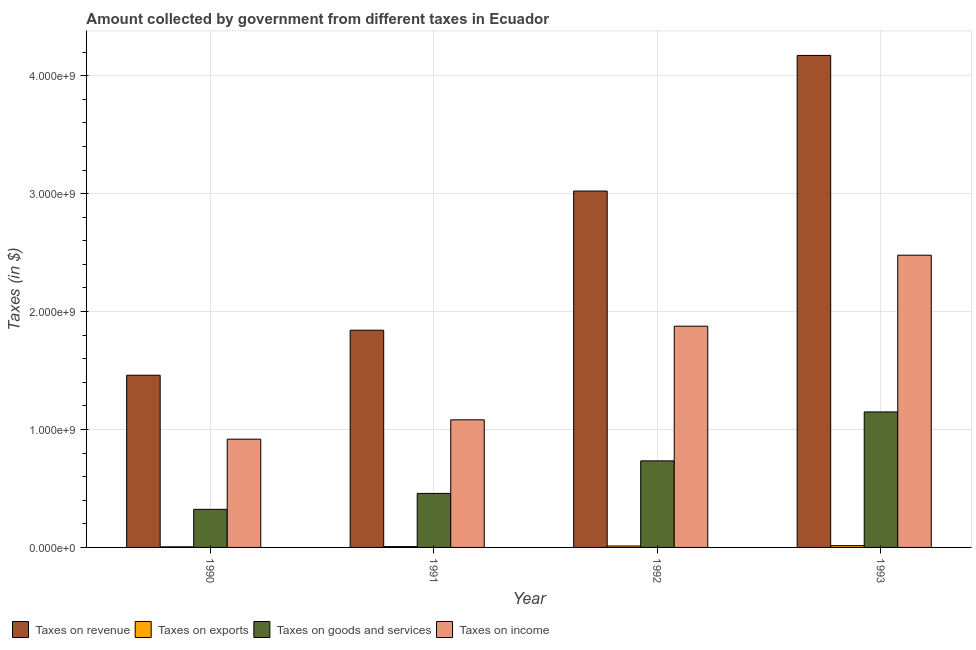How many different coloured bars are there?
Ensure brevity in your answer.  4. How many groups of bars are there?
Offer a very short reply. 4. Are the number of bars per tick equal to the number of legend labels?
Provide a succinct answer. Yes. How many bars are there on the 3rd tick from the right?
Ensure brevity in your answer.  4. What is the label of the 2nd group of bars from the left?
Provide a succinct answer. 1991. In how many cases, is the number of bars for a given year not equal to the number of legend labels?
Give a very brief answer. 0. What is the amount collected as tax on exports in 1993?
Provide a succinct answer. 1.50e+07. Across all years, what is the maximum amount collected as tax on goods?
Keep it short and to the point. 1.15e+09. Across all years, what is the minimum amount collected as tax on income?
Ensure brevity in your answer.  9.18e+08. What is the total amount collected as tax on revenue in the graph?
Your response must be concise. 1.05e+1. What is the difference between the amount collected as tax on revenue in 1990 and that in 1991?
Your answer should be very brief. -3.82e+08. What is the difference between the amount collected as tax on income in 1993 and the amount collected as tax on exports in 1991?
Your answer should be compact. 1.40e+09. What is the average amount collected as tax on exports per year?
Ensure brevity in your answer.  9.75e+06. In the year 1990, what is the difference between the amount collected as tax on income and amount collected as tax on revenue?
Offer a very short reply. 0. What is the ratio of the amount collected as tax on revenue in 1991 to that in 1993?
Make the answer very short. 0.44. What is the difference between the highest and the second highest amount collected as tax on revenue?
Offer a terse response. 1.15e+09. What is the difference between the highest and the lowest amount collected as tax on income?
Ensure brevity in your answer.  1.56e+09. Is the sum of the amount collected as tax on income in 1992 and 1993 greater than the maximum amount collected as tax on revenue across all years?
Provide a succinct answer. Yes. What does the 1st bar from the left in 1991 represents?
Make the answer very short. Taxes on revenue. What does the 1st bar from the right in 1993 represents?
Keep it short and to the point. Taxes on income. How many bars are there?
Your response must be concise. 16. Are all the bars in the graph horizontal?
Make the answer very short. No. Are the values on the major ticks of Y-axis written in scientific E-notation?
Your answer should be very brief. Yes. Does the graph contain any zero values?
Ensure brevity in your answer.  No. What is the title of the graph?
Your answer should be compact. Amount collected by government from different taxes in Ecuador. Does "Gender equality" appear as one of the legend labels in the graph?
Keep it short and to the point. No. What is the label or title of the Y-axis?
Your answer should be compact. Taxes (in $). What is the Taxes (in $) in Taxes on revenue in 1990?
Your answer should be compact. 1.46e+09. What is the Taxes (in $) in Taxes on exports in 1990?
Provide a short and direct response. 5.00e+06. What is the Taxes (in $) in Taxes on goods and services in 1990?
Keep it short and to the point. 3.23e+08. What is the Taxes (in $) in Taxes on income in 1990?
Provide a succinct answer. 9.18e+08. What is the Taxes (in $) in Taxes on revenue in 1991?
Offer a terse response. 1.84e+09. What is the Taxes (in $) in Taxes on exports in 1991?
Your answer should be compact. 7.00e+06. What is the Taxes (in $) of Taxes on goods and services in 1991?
Keep it short and to the point. 4.58e+08. What is the Taxes (in $) of Taxes on income in 1991?
Keep it short and to the point. 1.08e+09. What is the Taxes (in $) in Taxes on revenue in 1992?
Provide a succinct answer. 3.02e+09. What is the Taxes (in $) in Taxes on goods and services in 1992?
Your answer should be compact. 7.34e+08. What is the Taxes (in $) in Taxes on income in 1992?
Provide a succinct answer. 1.88e+09. What is the Taxes (in $) of Taxes on revenue in 1993?
Provide a succinct answer. 4.17e+09. What is the Taxes (in $) of Taxes on exports in 1993?
Give a very brief answer. 1.50e+07. What is the Taxes (in $) of Taxes on goods and services in 1993?
Provide a succinct answer. 1.15e+09. What is the Taxes (in $) in Taxes on income in 1993?
Your response must be concise. 2.48e+09. Across all years, what is the maximum Taxes (in $) in Taxes on revenue?
Make the answer very short. 4.17e+09. Across all years, what is the maximum Taxes (in $) of Taxes on exports?
Provide a succinct answer. 1.50e+07. Across all years, what is the maximum Taxes (in $) in Taxes on goods and services?
Keep it short and to the point. 1.15e+09. Across all years, what is the maximum Taxes (in $) in Taxes on income?
Make the answer very short. 2.48e+09. Across all years, what is the minimum Taxes (in $) in Taxes on revenue?
Give a very brief answer. 1.46e+09. Across all years, what is the minimum Taxes (in $) in Taxes on exports?
Keep it short and to the point. 5.00e+06. Across all years, what is the minimum Taxes (in $) of Taxes on goods and services?
Ensure brevity in your answer.  3.23e+08. Across all years, what is the minimum Taxes (in $) of Taxes on income?
Your answer should be compact. 9.18e+08. What is the total Taxes (in $) in Taxes on revenue in the graph?
Give a very brief answer. 1.05e+1. What is the total Taxes (in $) in Taxes on exports in the graph?
Keep it short and to the point. 3.90e+07. What is the total Taxes (in $) of Taxes on goods and services in the graph?
Your answer should be compact. 2.66e+09. What is the total Taxes (in $) in Taxes on income in the graph?
Keep it short and to the point. 6.35e+09. What is the difference between the Taxes (in $) of Taxes on revenue in 1990 and that in 1991?
Offer a very short reply. -3.82e+08. What is the difference between the Taxes (in $) in Taxes on exports in 1990 and that in 1991?
Your answer should be very brief. -2.00e+06. What is the difference between the Taxes (in $) in Taxes on goods and services in 1990 and that in 1991?
Give a very brief answer. -1.35e+08. What is the difference between the Taxes (in $) in Taxes on income in 1990 and that in 1991?
Provide a short and direct response. -1.64e+08. What is the difference between the Taxes (in $) of Taxes on revenue in 1990 and that in 1992?
Your response must be concise. -1.56e+09. What is the difference between the Taxes (in $) in Taxes on exports in 1990 and that in 1992?
Provide a short and direct response. -7.00e+06. What is the difference between the Taxes (in $) of Taxes on goods and services in 1990 and that in 1992?
Your response must be concise. -4.11e+08. What is the difference between the Taxes (in $) in Taxes on income in 1990 and that in 1992?
Your answer should be very brief. -9.58e+08. What is the difference between the Taxes (in $) in Taxes on revenue in 1990 and that in 1993?
Make the answer very short. -2.71e+09. What is the difference between the Taxes (in $) of Taxes on exports in 1990 and that in 1993?
Provide a short and direct response. -1.00e+07. What is the difference between the Taxes (in $) in Taxes on goods and services in 1990 and that in 1993?
Offer a very short reply. -8.26e+08. What is the difference between the Taxes (in $) of Taxes on income in 1990 and that in 1993?
Your response must be concise. -1.56e+09. What is the difference between the Taxes (in $) in Taxes on revenue in 1991 and that in 1992?
Offer a very short reply. -1.18e+09. What is the difference between the Taxes (in $) in Taxes on exports in 1991 and that in 1992?
Your response must be concise. -5.00e+06. What is the difference between the Taxes (in $) in Taxes on goods and services in 1991 and that in 1992?
Make the answer very short. -2.76e+08. What is the difference between the Taxes (in $) in Taxes on income in 1991 and that in 1992?
Your answer should be compact. -7.94e+08. What is the difference between the Taxes (in $) in Taxes on revenue in 1991 and that in 1993?
Your answer should be very brief. -2.33e+09. What is the difference between the Taxes (in $) of Taxes on exports in 1991 and that in 1993?
Your response must be concise. -8.00e+06. What is the difference between the Taxes (in $) of Taxes on goods and services in 1991 and that in 1993?
Offer a terse response. -6.91e+08. What is the difference between the Taxes (in $) in Taxes on income in 1991 and that in 1993?
Give a very brief answer. -1.40e+09. What is the difference between the Taxes (in $) of Taxes on revenue in 1992 and that in 1993?
Keep it short and to the point. -1.15e+09. What is the difference between the Taxes (in $) in Taxes on goods and services in 1992 and that in 1993?
Offer a terse response. -4.15e+08. What is the difference between the Taxes (in $) of Taxes on income in 1992 and that in 1993?
Your response must be concise. -6.02e+08. What is the difference between the Taxes (in $) in Taxes on revenue in 1990 and the Taxes (in $) in Taxes on exports in 1991?
Offer a terse response. 1.45e+09. What is the difference between the Taxes (in $) in Taxes on revenue in 1990 and the Taxes (in $) in Taxes on goods and services in 1991?
Your answer should be very brief. 1.00e+09. What is the difference between the Taxes (in $) of Taxes on revenue in 1990 and the Taxes (in $) of Taxes on income in 1991?
Provide a succinct answer. 3.78e+08. What is the difference between the Taxes (in $) of Taxes on exports in 1990 and the Taxes (in $) of Taxes on goods and services in 1991?
Provide a short and direct response. -4.53e+08. What is the difference between the Taxes (in $) of Taxes on exports in 1990 and the Taxes (in $) of Taxes on income in 1991?
Ensure brevity in your answer.  -1.08e+09. What is the difference between the Taxes (in $) of Taxes on goods and services in 1990 and the Taxes (in $) of Taxes on income in 1991?
Your answer should be compact. -7.59e+08. What is the difference between the Taxes (in $) of Taxes on revenue in 1990 and the Taxes (in $) of Taxes on exports in 1992?
Provide a succinct answer. 1.45e+09. What is the difference between the Taxes (in $) of Taxes on revenue in 1990 and the Taxes (in $) of Taxes on goods and services in 1992?
Offer a very short reply. 7.26e+08. What is the difference between the Taxes (in $) in Taxes on revenue in 1990 and the Taxes (in $) in Taxes on income in 1992?
Give a very brief answer. -4.16e+08. What is the difference between the Taxes (in $) in Taxes on exports in 1990 and the Taxes (in $) in Taxes on goods and services in 1992?
Give a very brief answer. -7.29e+08. What is the difference between the Taxes (in $) of Taxes on exports in 1990 and the Taxes (in $) of Taxes on income in 1992?
Ensure brevity in your answer.  -1.87e+09. What is the difference between the Taxes (in $) of Taxes on goods and services in 1990 and the Taxes (in $) of Taxes on income in 1992?
Your answer should be very brief. -1.55e+09. What is the difference between the Taxes (in $) in Taxes on revenue in 1990 and the Taxes (in $) in Taxes on exports in 1993?
Offer a very short reply. 1.44e+09. What is the difference between the Taxes (in $) of Taxes on revenue in 1990 and the Taxes (in $) of Taxes on goods and services in 1993?
Your answer should be very brief. 3.11e+08. What is the difference between the Taxes (in $) of Taxes on revenue in 1990 and the Taxes (in $) of Taxes on income in 1993?
Make the answer very short. -1.02e+09. What is the difference between the Taxes (in $) of Taxes on exports in 1990 and the Taxes (in $) of Taxes on goods and services in 1993?
Provide a short and direct response. -1.14e+09. What is the difference between the Taxes (in $) of Taxes on exports in 1990 and the Taxes (in $) of Taxes on income in 1993?
Provide a short and direct response. -2.47e+09. What is the difference between the Taxes (in $) in Taxes on goods and services in 1990 and the Taxes (in $) in Taxes on income in 1993?
Your answer should be very brief. -2.16e+09. What is the difference between the Taxes (in $) in Taxes on revenue in 1991 and the Taxes (in $) in Taxes on exports in 1992?
Your response must be concise. 1.83e+09. What is the difference between the Taxes (in $) in Taxes on revenue in 1991 and the Taxes (in $) in Taxes on goods and services in 1992?
Offer a terse response. 1.11e+09. What is the difference between the Taxes (in $) in Taxes on revenue in 1991 and the Taxes (in $) in Taxes on income in 1992?
Give a very brief answer. -3.40e+07. What is the difference between the Taxes (in $) in Taxes on exports in 1991 and the Taxes (in $) in Taxes on goods and services in 1992?
Provide a short and direct response. -7.27e+08. What is the difference between the Taxes (in $) of Taxes on exports in 1991 and the Taxes (in $) of Taxes on income in 1992?
Offer a very short reply. -1.87e+09. What is the difference between the Taxes (in $) of Taxes on goods and services in 1991 and the Taxes (in $) of Taxes on income in 1992?
Your response must be concise. -1.42e+09. What is the difference between the Taxes (in $) of Taxes on revenue in 1991 and the Taxes (in $) of Taxes on exports in 1993?
Ensure brevity in your answer.  1.83e+09. What is the difference between the Taxes (in $) in Taxes on revenue in 1991 and the Taxes (in $) in Taxes on goods and services in 1993?
Offer a very short reply. 6.93e+08. What is the difference between the Taxes (in $) in Taxes on revenue in 1991 and the Taxes (in $) in Taxes on income in 1993?
Make the answer very short. -6.36e+08. What is the difference between the Taxes (in $) of Taxes on exports in 1991 and the Taxes (in $) of Taxes on goods and services in 1993?
Offer a terse response. -1.14e+09. What is the difference between the Taxes (in $) of Taxes on exports in 1991 and the Taxes (in $) of Taxes on income in 1993?
Provide a short and direct response. -2.47e+09. What is the difference between the Taxes (in $) in Taxes on goods and services in 1991 and the Taxes (in $) in Taxes on income in 1993?
Provide a succinct answer. -2.02e+09. What is the difference between the Taxes (in $) in Taxes on revenue in 1992 and the Taxes (in $) in Taxes on exports in 1993?
Your answer should be very brief. 3.01e+09. What is the difference between the Taxes (in $) in Taxes on revenue in 1992 and the Taxes (in $) in Taxes on goods and services in 1993?
Provide a succinct answer. 1.87e+09. What is the difference between the Taxes (in $) in Taxes on revenue in 1992 and the Taxes (in $) in Taxes on income in 1993?
Provide a short and direct response. 5.44e+08. What is the difference between the Taxes (in $) in Taxes on exports in 1992 and the Taxes (in $) in Taxes on goods and services in 1993?
Your answer should be very brief. -1.14e+09. What is the difference between the Taxes (in $) of Taxes on exports in 1992 and the Taxes (in $) of Taxes on income in 1993?
Your answer should be compact. -2.47e+09. What is the difference between the Taxes (in $) in Taxes on goods and services in 1992 and the Taxes (in $) in Taxes on income in 1993?
Make the answer very short. -1.74e+09. What is the average Taxes (in $) in Taxes on revenue per year?
Keep it short and to the point. 2.62e+09. What is the average Taxes (in $) in Taxes on exports per year?
Give a very brief answer. 9.75e+06. What is the average Taxes (in $) of Taxes on goods and services per year?
Your answer should be very brief. 6.66e+08. What is the average Taxes (in $) in Taxes on income per year?
Your answer should be very brief. 1.59e+09. In the year 1990, what is the difference between the Taxes (in $) of Taxes on revenue and Taxes (in $) of Taxes on exports?
Ensure brevity in your answer.  1.46e+09. In the year 1990, what is the difference between the Taxes (in $) of Taxes on revenue and Taxes (in $) of Taxes on goods and services?
Offer a terse response. 1.14e+09. In the year 1990, what is the difference between the Taxes (in $) in Taxes on revenue and Taxes (in $) in Taxes on income?
Ensure brevity in your answer.  5.42e+08. In the year 1990, what is the difference between the Taxes (in $) of Taxes on exports and Taxes (in $) of Taxes on goods and services?
Your response must be concise. -3.18e+08. In the year 1990, what is the difference between the Taxes (in $) of Taxes on exports and Taxes (in $) of Taxes on income?
Give a very brief answer. -9.13e+08. In the year 1990, what is the difference between the Taxes (in $) in Taxes on goods and services and Taxes (in $) in Taxes on income?
Offer a terse response. -5.95e+08. In the year 1991, what is the difference between the Taxes (in $) in Taxes on revenue and Taxes (in $) in Taxes on exports?
Make the answer very short. 1.84e+09. In the year 1991, what is the difference between the Taxes (in $) of Taxes on revenue and Taxes (in $) of Taxes on goods and services?
Your response must be concise. 1.38e+09. In the year 1991, what is the difference between the Taxes (in $) of Taxes on revenue and Taxes (in $) of Taxes on income?
Offer a terse response. 7.60e+08. In the year 1991, what is the difference between the Taxes (in $) in Taxes on exports and Taxes (in $) in Taxes on goods and services?
Give a very brief answer. -4.51e+08. In the year 1991, what is the difference between the Taxes (in $) of Taxes on exports and Taxes (in $) of Taxes on income?
Provide a short and direct response. -1.08e+09. In the year 1991, what is the difference between the Taxes (in $) in Taxes on goods and services and Taxes (in $) in Taxes on income?
Offer a terse response. -6.24e+08. In the year 1992, what is the difference between the Taxes (in $) in Taxes on revenue and Taxes (in $) in Taxes on exports?
Offer a very short reply. 3.01e+09. In the year 1992, what is the difference between the Taxes (in $) in Taxes on revenue and Taxes (in $) in Taxes on goods and services?
Your response must be concise. 2.29e+09. In the year 1992, what is the difference between the Taxes (in $) of Taxes on revenue and Taxes (in $) of Taxes on income?
Provide a succinct answer. 1.15e+09. In the year 1992, what is the difference between the Taxes (in $) in Taxes on exports and Taxes (in $) in Taxes on goods and services?
Your answer should be very brief. -7.22e+08. In the year 1992, what is the difference between the Taxes (in $) of Taxes on exports and Taxes (in $) of Taxes on income?
Ensure brevity in your answer.  -1.86e+09. In the year 1992, what is the difference between the Taxes (in $) in Taxes on goods and services and Taxes (in $) in Taxes on income?
Offer a terse response. -1.14e+09. In the year 1993, what is the difference between the Taxes (in $) in Taxes on revenue and Taxes (in $) in Taxes on exports?
Provide a succinct answer. 4.16e+09. In the year 1993, what is the difference between the Taxes (in $) in Taxes on revenue and Taxes (in $) in Taxes on goods and services?
Provide a succinct answer. 3.02e+09. In the year 1993, what is the difference between the Taxes (in $) of Taxes on revenue and Taxes (in $) of Taxes on income?
Your answer should be compact. 1.69e+09. In the year 1993, what is the difference between the Taxes (in $) in Taxes on exports and Taxes (in $) in Taxes on goods and services?
Your answer should be very brief. -1.13e+09. In the year 1993, what is the difference between the Taxes (in $) of Taxes on exports and Taxes (in $) of Taxes on income?
Your response must be concise. -2.46e+09. In the year 1993, what is the difference between the Taxes (in $) in Taxes on goods and services and Taxes (in $) in Taxes on income?
Your response must be concise. -1.33e+09. What is the ratio of the Taxes (in $) in Taxes on revenue in 1990 to that in 1991?
Your answer should be compact. 0.79. What is the ratio of the Taxes (in $) in Taxes on exports in 1990 to that in 1991?
Provide a short and direct response. 0.71. What is the ratio of the Taxes (in $) in Taxes on goods and services in 1990 to that in 1991?
Your response must be concise. 0.71. What is the ratio of the Taxes (in $) of Taxes on income in 1990 to that in 1991?
Your response must be concise. 0.85. What is the ratio of the Taxes (in $) in Taxes on revenue in 1990 to that in 1992?
Provide a short and direct response. 0.48. What is the ratio of the Taxes (in $) of Taxes on exports in 1990 to that in 1992?
Your response must be concise. 0.42. What is the ratio of the Taxes (in $) of Taxes on goods and services in 1990 to that in 1992?
Keep it short and to the point. 0.44. What is the ratio of the Taxes (in $) of Taxes on income in 1990 to that in 1992?
Keep it short and to the point. 0.49. What is the ratio of the Taxes (in $) of Taxes on goods and services in 1990 to that in 1993?
Give a very brief answer. 0.28. What is the ratio of the Taxes (in $) in Taxes on income in 1990 to that in 1993?
Make the answer very short. 0.37. What is the ratio of the Taxes (in $) in Taxes on revenue in 1991 to that in 1992?
Make the answer very short. 0.61. What is the ratio of the Taxes (in $) in Taxes on exports in 1991 to that in 1992?
Provide a short and direct response. 0.58. What is the ratio of the Taxes (in $) in Taxes on goods and services in 1991 to that in 1992?
Make the answer very short. 0.62. What is the ratio of the Taxes (in $) in Taxes on income in 1991 to that in 1992?
Offer a very short reply. 0.58. What is the ratio of the Taxes (in $) of Taxes on revenue in 1991 to that in 1993?
Provide a short and direct response. 0.44. What is the ratio of the Taxes (in $) of Taxes on exports in 1991 to that in 1993?
Offer a terse response. 0.47. What is the ratio of the Taxes (in $) of Taxes on goods and services in 1991 to that in 1993?
Provide a succinct answer. 0.4. What is the ratio of the Taxes (in $) of Taxes on income in 1991 to that in 1993?
Your response must be concise. 0.44. What is the ratio of the Taxes (in $) in Taxes on revenue in 1992 to that in 1993?
Offer a very short reply. 0.72. What is the ratio of the Taxes (in $) of Taxes on exports in 1992 to that in 1993?
Your answer should be very brief. 0.8. What is the ratio of the Taxes (in $) of Taxes on goods and services in 1992 to that in 1993?
Make the answer very short. 0.64. What is the ratio of the Taxes (in $) in Taxes on income in 1992 to that in 1993?
Give a very brief answer. 0.76. What is the difference between the highest and the second highest Taxes (in $) in Taxes on revenue?
Offer a terse response. 1.15e+09. What is the difference between the highest and the second highest Taxes (in $) of Taxes on goods and services?
Provide a succinct answer. 4.15e+08. What is the difference between the highest and the second highest Taxes (in $) in Taxes on income?
Offer a terse response. 6.02e+08. What is the difference between the highest and the lowest Taxes (in $) in Taxes on revenue?
Give a very brief answer. 2.71e+09. What is the difference between the highest and the lowest Taxes (in $) of Taxes on exports?
Your answer should be very brief. 1.00e+07. What is the difference between the highest and the lowest Taxes (in $) in Taxes on goods and services?
Ensure brevity in your answer.  8.26e+08. What is the difference between the highest and the lowest Taxes (in $) of Taxes on income?
Offer a very short reply. 1.56e+09. 